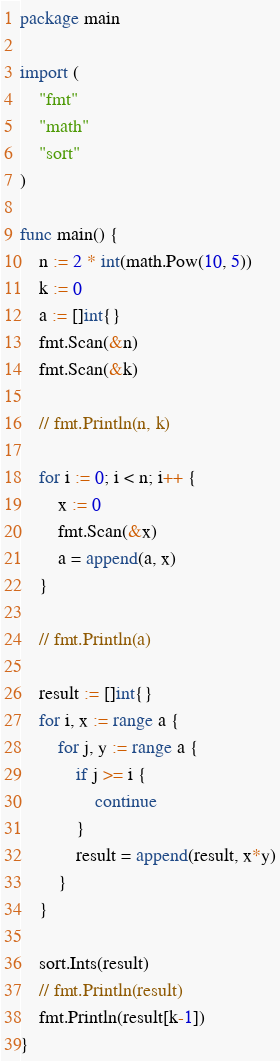<code> <loc_0><loc_0><loc_500><loc_500><_Go_>package main

import (
	"fmt"
	"math"
	"sort"
)

func main() {
	n := 2 * int(math.Pow(10, 5))
	k := 0
	a := []int{}
	fmt.Scan(&n)
	fmt.Scan(&k)

	// fmt.Println(n, k)

	for i := 0; i < n; i++ {
		x := 0
		fmt.Scan(&x)
		a = append(a, x)
	}

	// fmt.Println(a)

	result := []int{}
	for i, x := range a {
		for j, y := range a {
			if j >= i {
				continue
			}
			result = append(result, x*y)
		}
	}

	sort.Ints(result)
	// fmt.Println(result)
	fmt.Println(result[k-1])
}
</code> 